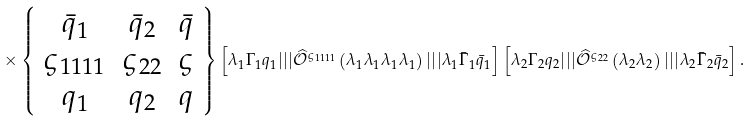Convert formula to latex. <formula><loc_0><loc_0><loc_500><loc_500>\times \left \{ \begin{array} { c c c } \bar { q } _ { 1 } & \bar { q } _ { 2 } & \bar { q } \\ \varsigma _ { 1 1 1 1 } & \varsigma _ { 2 2 } & \varsigma \\ q _ { 1 } & q _ { 2 } & q \end{array} \right \} \left [ \lambda _ { 1 } \Gamma _ { 1 } q _ { 1 } | | | \widehat { \mathcal { O } } ^ { \varsigma _ { 1 1 1 1 } } \left ( \lambda _ { 1 } \lambda _ { 1 } \lambda _ { 1 } \lambda _ { 1 } \right ) | | | \lambda _ { 1 } \bar { \Gamma } _ { 1 } \bar { q } _ { 1 } \right ] \left [ \lambda _ { 2 } \Gamma _ { 2 } q _ { 2 } | | | \widehat { \mathcal { O } } ^ { \varsigma _ { 2 2 } } \left ( \lambda _ { 2 } \lambda _ { 2 } \right ) | | | \lambda _ { 2 } \bar { \Gamma } _ { 2 } \bar { q } _ { 2 } \right ] .</formula> 